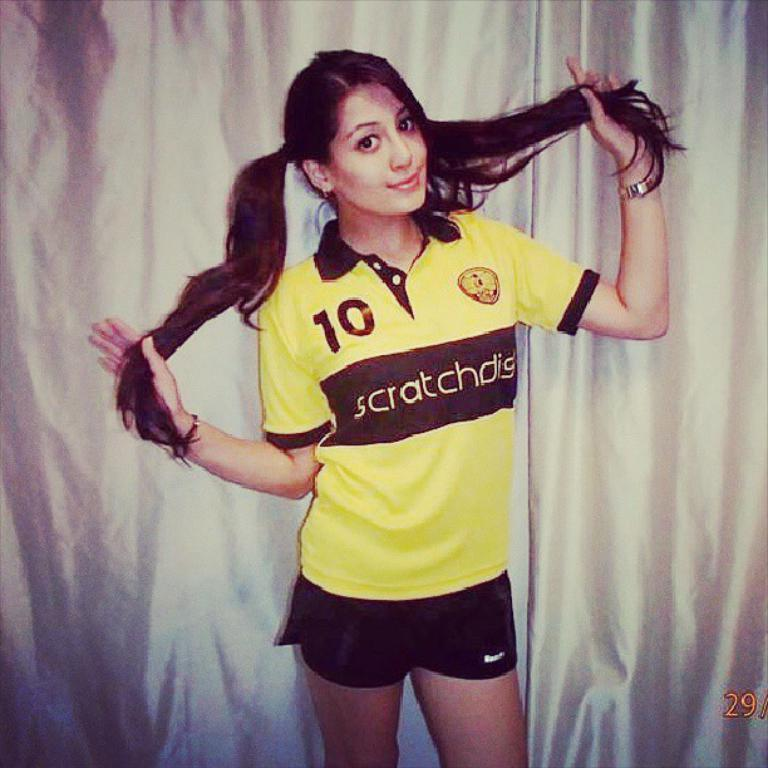Provide a one-sentence caption for the provided image. A girl standing with her hair in pig tails and wearing a sports outfit that says SCRATCHDIG on the front. 